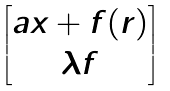<formula> <loc_0><loc_0><loc_500><loc_500>\begin{bmatrix} a x + f ( r ) \\ \lambda f \end{bmatrix}</formula> 